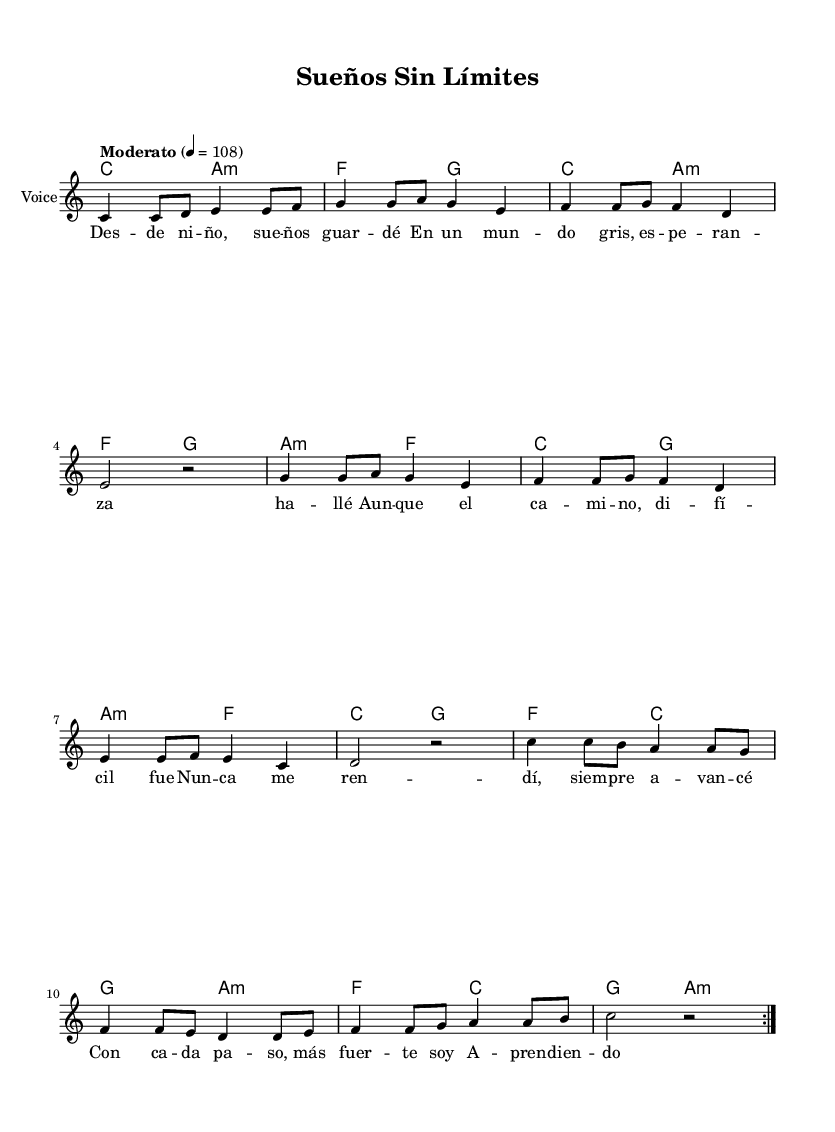What is the key signature of this music? The key signature is indicated at the beginning of the score and shows no sharps or flats, meaning it is in C major.
Answer: C major What is the time signature of this piece? The time signature is shown at the beginning of the score, which indicates that there are four beats per measure and is written as 4/4.
Answer: 4/4 What is the tempo marking of this music? The tempo marking in the score states "Moderato" and provides a metronome marking of 108, which suggests a moderate speed.
Answer: Moderato How many times is the melody repeated in the score? The melody section contains a repeat indication "volta 2," meaning it is to be played twice in total.
Answer: 2 What is the first line of the lyrics in the verse? The first line of the lyrics appears directly beneath the melody and reads "Des -- de ni -- ño, sue -- ños guar -- dé."
Answer: Des -- de ni -- ño, sue -- ños guar -- dé What musical element indicates the harmony in this score? The harmony is shown as chords in the chord mode section of the score, labeled with chord names like C, A minor, F, and G.
Answer: Chords What theme do the lyrics of this song convey? The lyrics focus on themes of hope and perseverance in the face of difficulties, emphasizing the importance of chasing dreams despite challenges.
Answer: Hope and perseverance 